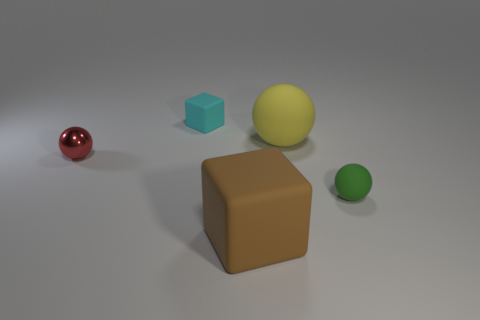Is there anything else that is the same material as the small red object?
Your answer should be compact. No. How many things are large yellow objects behind the large brown rubber block or tiny green matte things?
Offer a very short reply. 2. What size is the block that is in front of the big rubber ball?
Your answer should be very brief. Large. Is the size of the red metal thing the same as the yellow rubber sphere behind the big brown block?
Ensure brevity in your answer.  No. The big thing that is behind the big brown object left of the large sphere is what color?
Provide a succinct answer. Yellow. The cyan block is what size?
Make the answer very short. Small. Are there more large yellow balls that are on the right side of the cyan rubber object than small green balls that are in front of the large cube?
Keep it short and to the point. Yes. There is a small cyan matte object left of the yellow sphere; what number of big yellow objects are on the right side of it?
Offer a very short reply. 1. There is a small thing right of the large rubber ball; is its shape the same as the tiny red metallic object?
Offer a terse response. Yes. There is a red object that is the same shape as the small green rubber thing; what is its material?
Offer a terse response. Metal. 